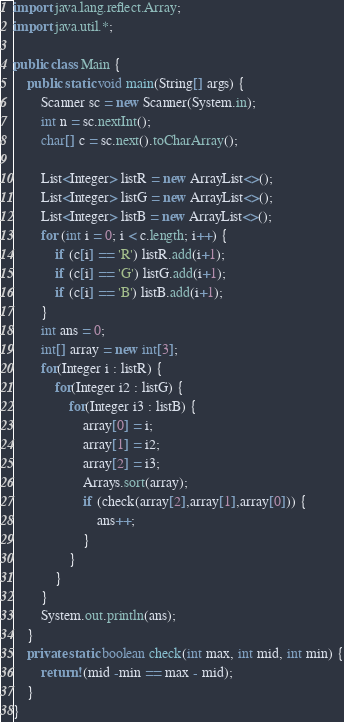Convert code to text. <code><loc_0><loc_0><loc_500><loc_500><_Java_>import java.lang.reflect.Array;
import java.util.*;

public class Main {
    public static void main(String[] args) {
        Scanner sc = new Scanner(System.in);
        int n = sc.nextInt();
        char[] c = sc.next().toCharArray();

        List<Integer> listR = new ArrayList<>();
        List<Integer> listG = new ArrayList<>();
        List<Integer> listB = new ArrayList<>();
        for (int i = 0; i < c.length; i++) {
            if (c[i] == 'R') listR.add(i+1);
            if (c[i] == 'G') listG.add(i+1);
            if (c[i] == 'B') listB.add(i+1);
        }
        int ans = 0;
        int[] array = new int[3];
        for(Integer i : listR) {
            for(Integer i2 : listG) {
                for(Integer i3 : listB) {
                    array[0] = i;
                    array[1] = i2;
                    array[2] = i3;
                    Arrays.sort(array);
                    if (check(array[2],array[1],array[0])) {
                        ans++;
                    }
                }
            }
        }
        System.out.println(ans);
    }
    private static boolean check(int max, int mid, int min) {
        return !(mid -min == max - mid);
    }
}

</code> 